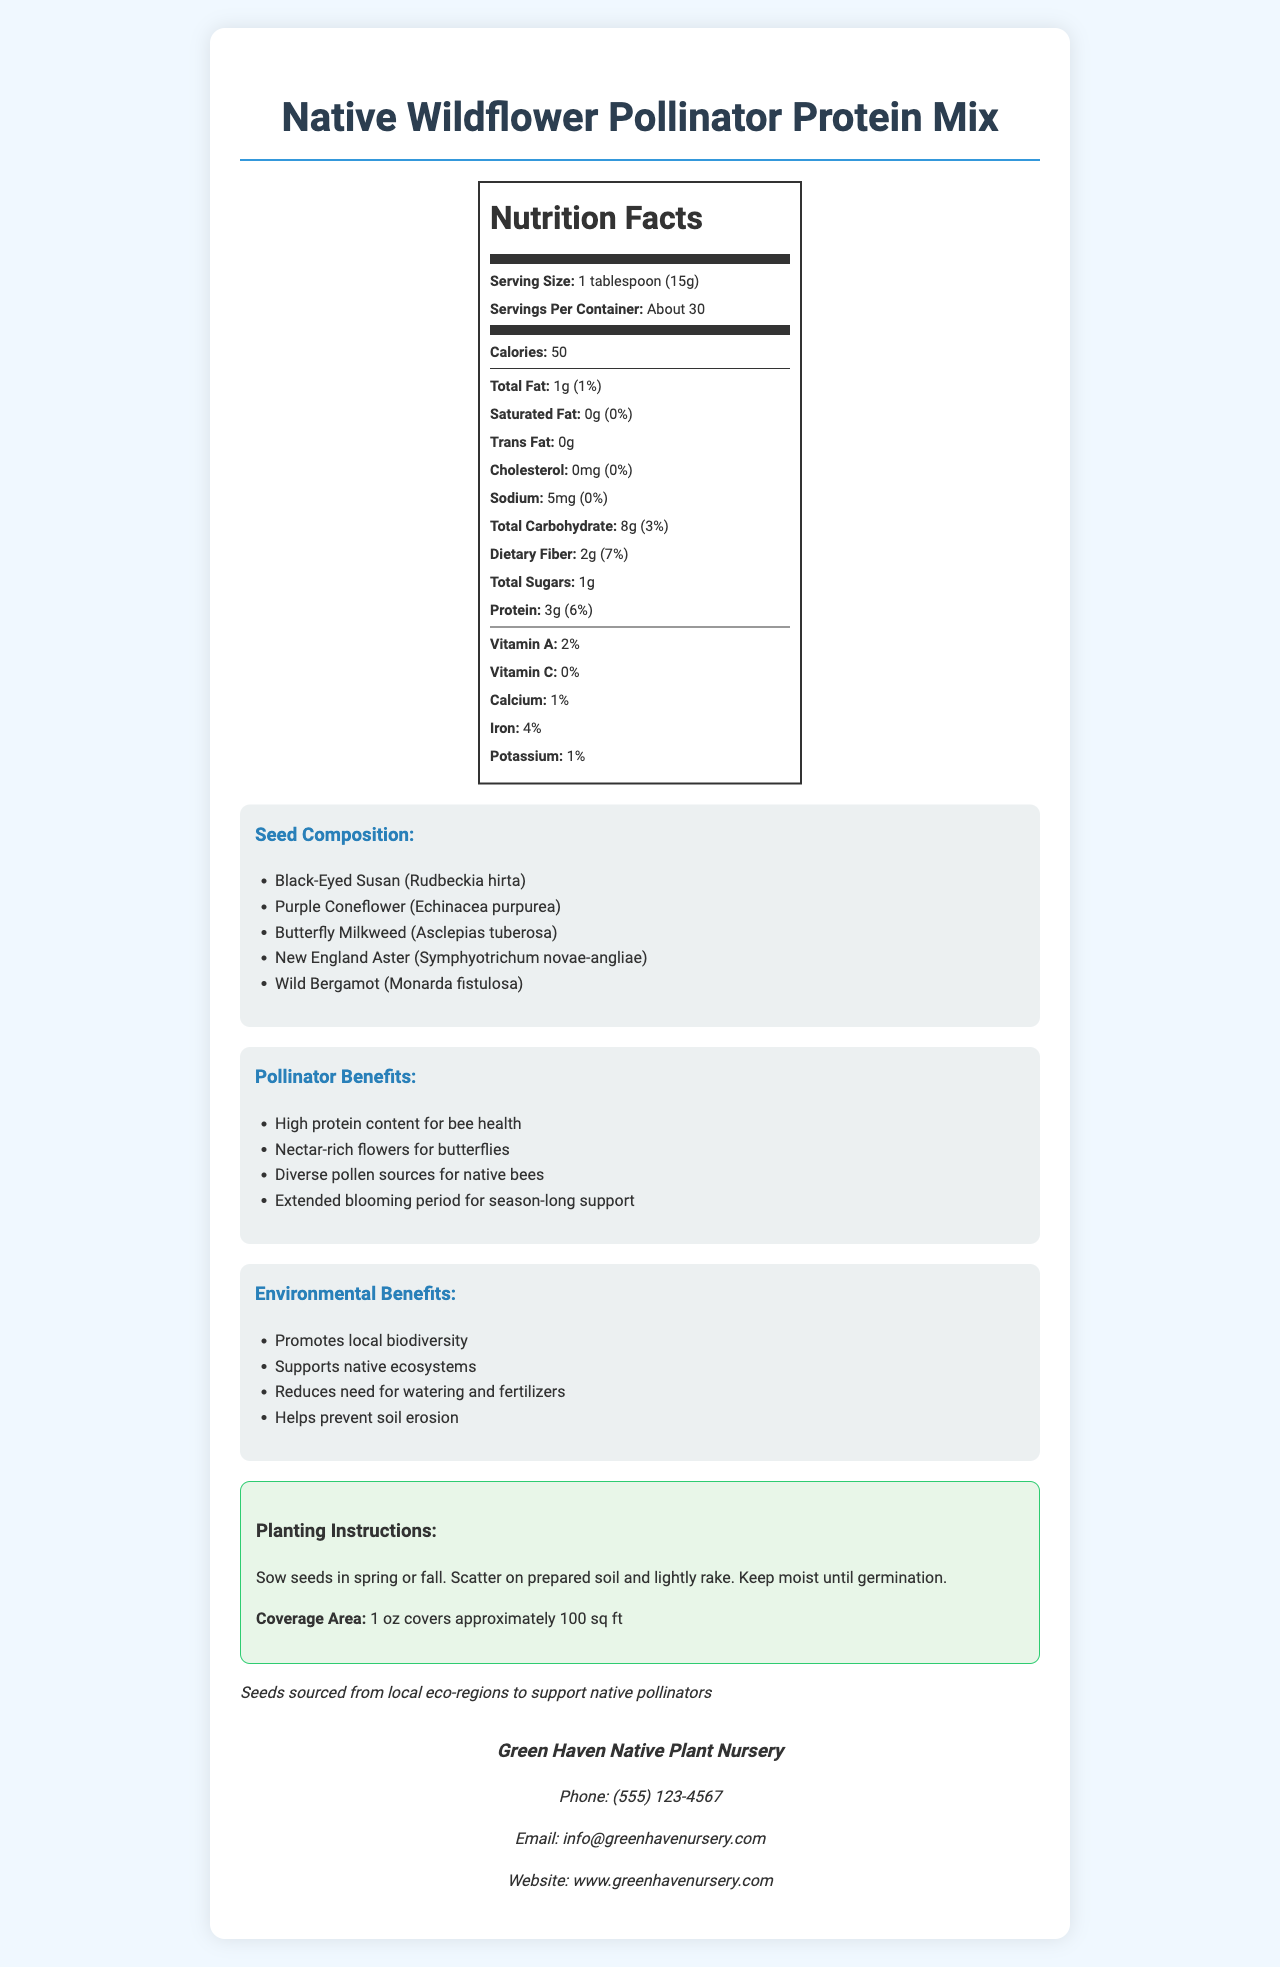What is the serving size for the Native Wildflower Pollinator Protein Mix? The document states under the "Nutrition Facts" section that the serving size is 1 tablespoon (15g).
Answer: 1 tablespoon (15g) How many grams of protein are in a single serving of the seed mix? The "Nutrition Facts" section lists the protein amount as 3g per serving.
Answer: 3g What percentage of the daily value of protein does each serving provide? According to the "Nutrition Facts" section, a serving provides 6% of the daily value for protein.
Answer: 6% Which plant species are included in the seed composition? The document lists the seed composition as including Black-Eyed Susan, Purple Coneflower, Butterfly Milkweed, New England Aster, and Wild Bergamot.
Answer: Black-Eyed Susan, Purple Coneflower, Butterfly Milkweed, New England Aster, Wild Bergamot What are the environmental benefits mentioned for the seed mix? The document lists these environmental benefits in the "Environmental Benefits" section.
Answer: Promotes local biodiversity, Supports native ecosystems, Reduces need for watering and fertilizers, Helps prevent soil erosion How many servings are there per container? According to the "Nutrition Facts" section, there are about 30 servings per container.
Answer: About 30 What is the total fat per serving, both in grams and as a percentage of daily value? The "Nutrition Facts" section specifies that the total fat per serving is 1g and 1% of the daily value.
Answer: 1g, 1% Multiple choice: Which of the following benefits is NOT listed under pollinator benefits? A. High protein content for bee health B. Supports native ecosystems C. Nectar-rich flowers for butterflies D. Diverse pollen sources for native bees The benefit "Supports native ecosystems" is listed under environmental benefits, not pollinator benefits.
Answer: B Multiple choice: How much calcium is in a serving? 1. 0% 2. 1% 3. 2% 4. 4% The "Nutrition Facts" section specifies that calcium is 1% of the daily value per serving.
Answer: 2. 1% Yes/No: Can the calcium content be affected by the geographical origin of the seeds? The document does not provide information on how the geographical origin of seeds affects calcium content.
Answer: Not enough information Summary: Could you describe the main idea of the document? The document provides comprehensive information including nutritional value, pollinator and environmental benefits, and practical instructions for planting the seed mix.
Answer: The document details the nutrition facts, seed composition, benefits, and planting instructions for the "Native Wildflower Pollinator Protein Mix." It highlights the high protein content for pollinators, environmental benefits, and ways to support local biodiversity and native ecosystems. How does the mix help in preventing soil erosion? The document specifically lists preventing soil erosion as one of the environmental benefits.
Answer: Helps prevent soil erosion What is the total carbohydrate content per serving? The "Nutrition Facts" section lists the total carbohydrate content as 8g per serving.
Answer: 8g What is the phone number provided for contact information? The "Contact Information" section lists the phone number as (555) 123-4567.
Answer: (555) 123-4567 How should the seeds be planted for optimal growth? The "Planting Instructions" section provides these steps for optimal growth.
Answer: Sow seeds in spring or fall, scatter on prepared soil, and lightly rake. Keep moist until germination. What is the source region of the seeds? The "Origin Statement" mentions that the seeds are sourced from local eco-regions to support native pollinators.
Answer: Local eco-regions What is the daily percentage value of dietary fiber per serving? The "Nutrition Facts" section lists the daily value percentage of dietary fiber as 7%.
Answer: 7% Can the document indicate if the seed mix is organic? The document does not mention whether the seed mix is organic or not.
Answer: Not enough information 